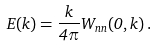<formula> <loc_0><loc_0><loc_500><loc_500>E ( k ) = \frac { k } { 4 \pi } W _ { n n } ( 0 , { k } ) \, .</formula> 